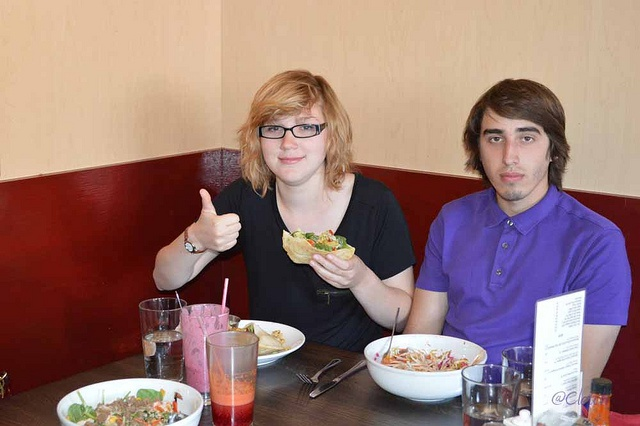Describe the objects in this image and their specific colors. I can see people in tan, black, darkgray, and lightgray tones, people in tan, blue, darkblue, and darkgray tones, bench in tan, maroon, black, gray, and brown tones, dining table in tan, maroon, black, and gray tones, and bowl in tan, white, darkgray, and gray tones in this image. 